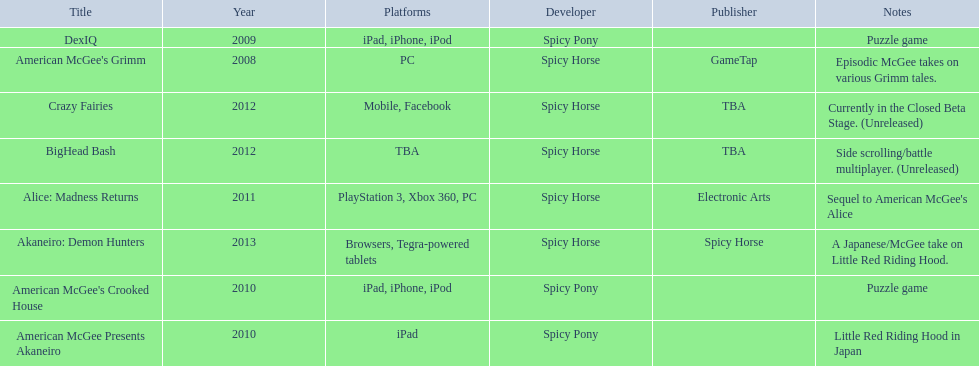What spicy horse titles are listed? American McGee's Grimm, DexIQ, American McGee Presents Akaneiro, American McGee's Crooked House, Alice: Madness Returns, BigHead Bash, Crazy Fairies, Akaneiro: Demon Hunters. Which of these can be used on ipad? DexIQ, American McGee Presents Akaneiro, American McGee's Crooked House. Which left cannot also be used on iphone or ipod? American McGee Presents Akaneiro. 